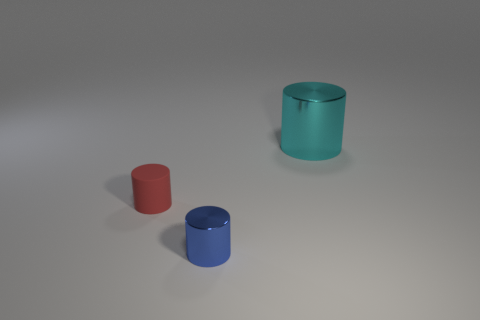Add 3 large cyan cylinders. How many objects exist? 6 Subtract all tiny blue cylinders. How many cylinders are left? 2 Subtract all red cylinders. How many cylinders are left? 2 Subtract all red rubber cylinders. Subtract all red objects. How many objects are left? 1 Add 2 tiny red matte cylinders. How many tiny red matte cylinders are left? 3 Add 1 red cylinders. How many red cylinders exist? 2 Subtract 0 brown blocks. How many objects are left? 3 Subtract all green cylinders. Subtract all brown blocks. How many cylinders are left? 3 